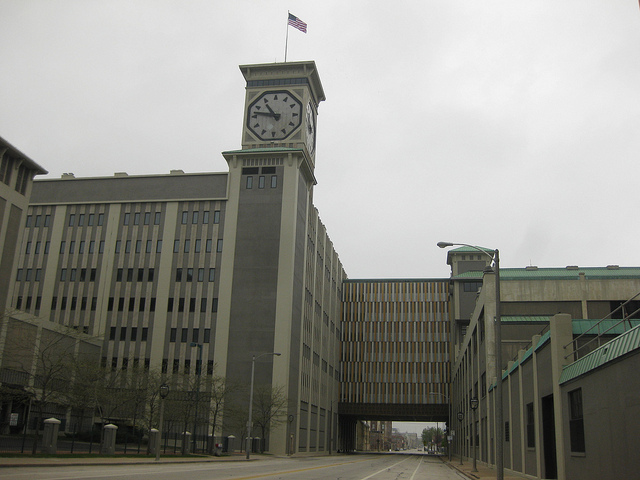<image>What color are the train tracks above the clock? It's ambiguous what the color of the train tracks above the clock is, as they might not even be in the image. What colors are the clocks? I am not sure what color the clocks are. They could be white, gray, black and white, or concrete color. What symbol is on top of the tower? It's uncertain what symbol is on top of the tower, it could either be an American flag or a clock. Is the time correct? I am not sure if the time is correct. Where is the crane? There is no crane in the image. What color are the train tracks above the clock? I am not sure what color the train tracks are above the clock. It can be seen white, gray, black or brown. What colors are the clocks? It is unanswerable what colors are the clocks. Is the time correct? I don't know if the time is correct. It could be yes or no. Where is the crane? There is no crane in the image. What symbol is on top of the tower? I am not sure what symbol is on top of the tower. It can be seen 'us flag', 'american flag', 'none', or 'clock'. 